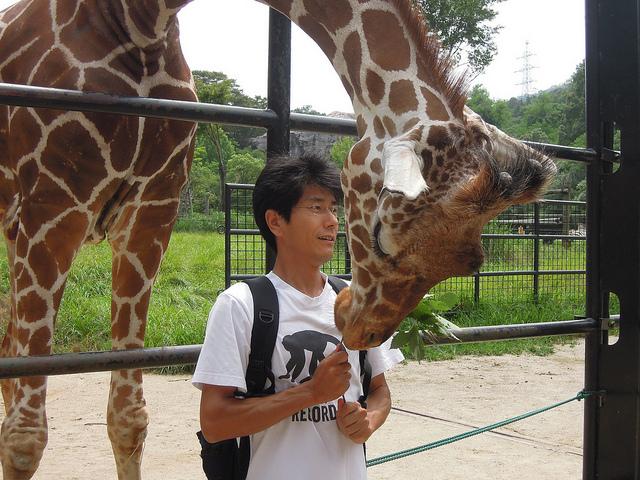Where is the giraffe looking?
Give a very brief answer. Down. Does the giraffe have two horns?
Be succinct. Yes. Does the man look afraid of the animal?
Concise answer only. No. Does the giraffe have its eyes open?
Write a very short answer. No. Is this in nature?
Answer briefly. No. What is the tallest creature in the image?
Answer briefly. Giraffe. Why have these animals been tagged?
Keep it brief. No. 